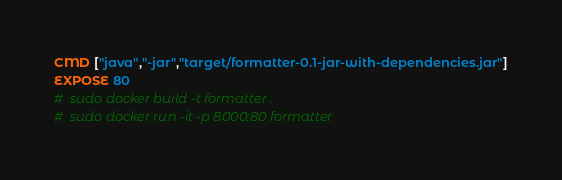<code> <loc_0><loc_0><loc_500><loc_500><_Dockerfile_>CMD ["java","-jar","target/formatter-0.1-jar-with-dependencies.jar"]
EXPOSE 80
#  sudo docker build -t formatter .
#  sudo docker run -it -p 8000:80 formatter</code> 